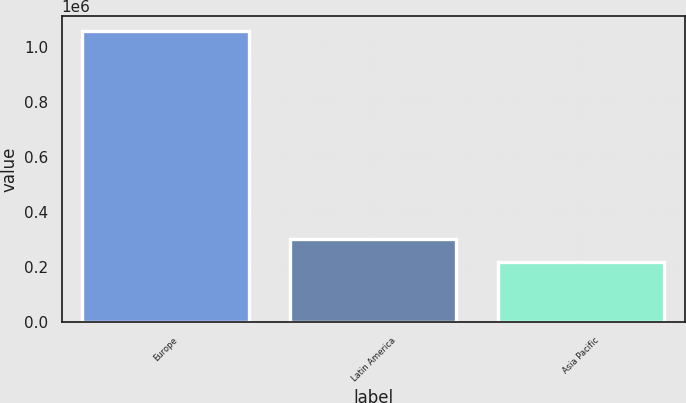<chart> <loc_0><loc_0><loc_500><loc_500><bar_chart><fcel>Europe<fcel>Latin America<fcel>Asia Pacific<nl><fcel>1.05794e+06<fcel>303933<fcel>220155<nl></chart> 